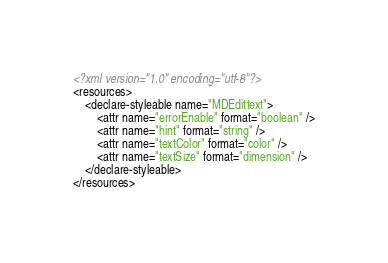Convert code to text. <code><loc_0><loc_0><loc_500><loc_500><_XML_><?xml version="1.0" encoding="utf-8"?>
<resources>
    <declare-styleable name="MDEdittext">
        <attr name="errorEnable" format="boolean" />
        <attr name="hint" format="string" />
        <attr name="textColor" format="color" />
        <attr name="textSize" format="dimension" />
    </declare-styleable>
</resources></code> 